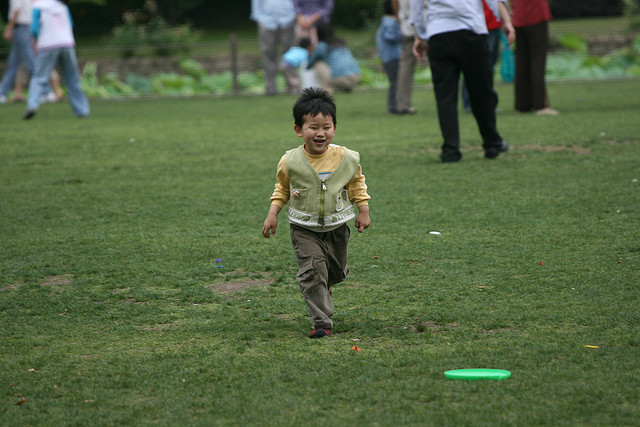Describe the surroundings where the child is. The child is in a park-like setting with expanses of green grass. There are blurred figures of other people in the background, indicating a public or communal space. 